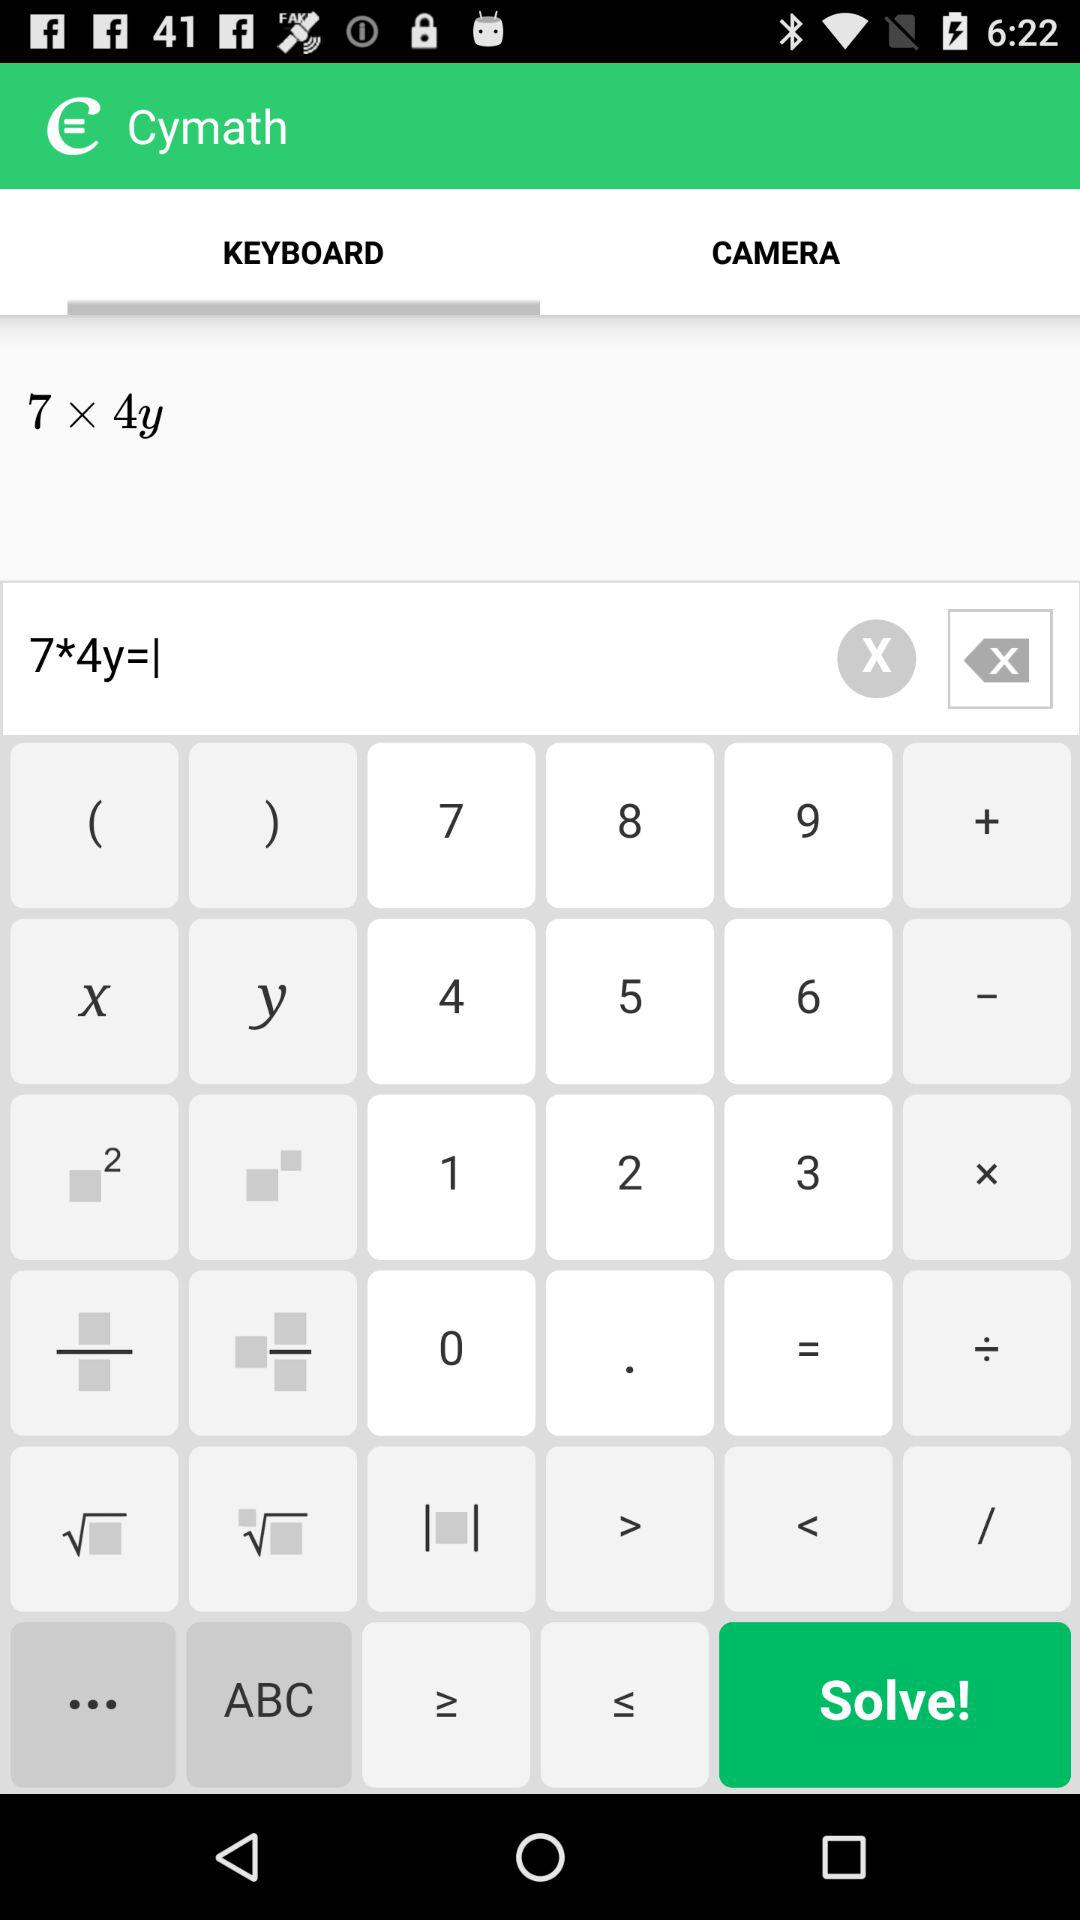Which tab is open? The open tab is "KEYBOARD". 